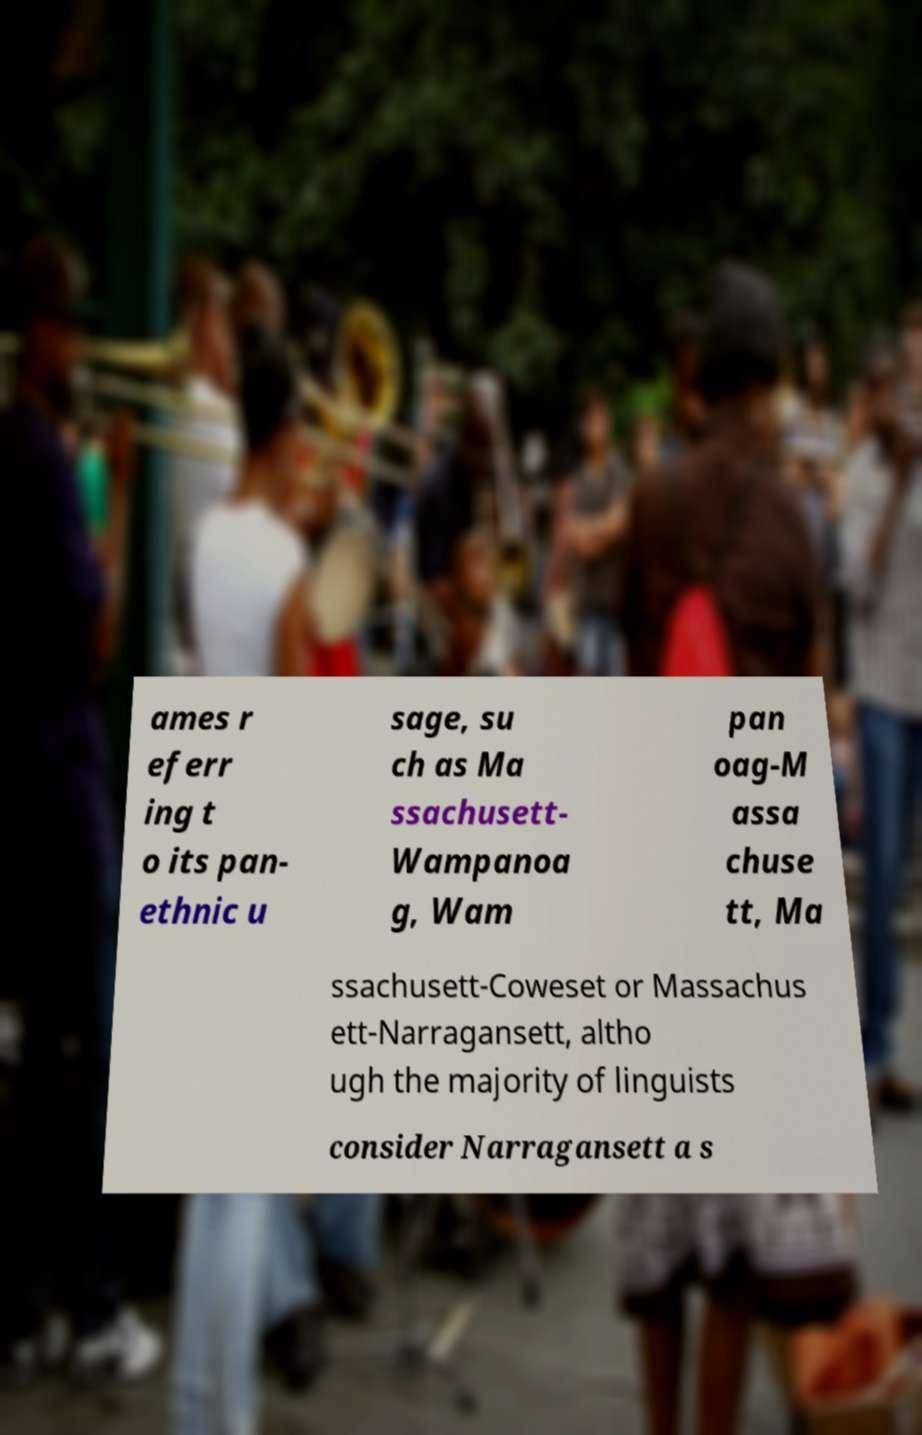I need the written content from this picture converted into text. Can you do that? ames r eferr ing t o its pan- ethnic u sage, su ch as Ma ssachusett- Wampanoa g, Wam pan oag-M assa chuse tt, Ma ssachusett-Coweset or Massachus ett-Narragansett, altho ugh the majority of linguists consider Narragansett a s 